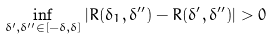<formula> <loc_0><loc_0><loc_500><loc_500>\inf _ { \delta ^ { \prime } , \delta ^ { \prime \prime } \in [ - \delta , \delta ] } | R ( \delta _ { 1 } , \delta ^ { \prime \prime } ) - R ( \delta ^ { \prime } , \delta ^ { \prime \prime } ) | > 0</formula> 